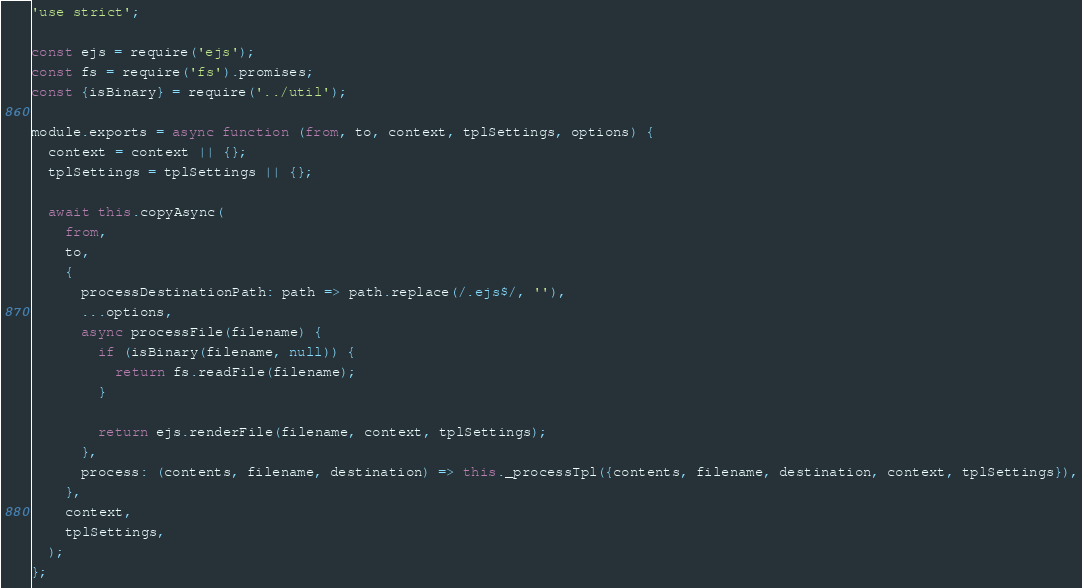<code> <loc_0><loc_0><loc_500><loc_500><_JavaScript_>'use strict';

const ejs = require('ejs');
const fs = require('fs').promises;
const {isBinary} = require('../util');

module.exports = async function (from, to, context, tplSettings, options) {
  context = context || {};
  tplSettings = tplSettings || {};

  await this.copyAsync(
    from,
    to,
    {
      processDestinationPath: path => path.replace(/.ejs$/, ''),
      ...options,
      async processFile(filename) {
        if (isBinary(filename, null)) {
          return fs.readFile(filename);
        }

        return ejs.renderFile(filename, context, tplSettings);
      },
      process: (contents, filename, destination) => this._processTpl({contents, filename, destination, context, tplSettings}),
    },
    context,
    tplSettings,
  );
};
</code> 